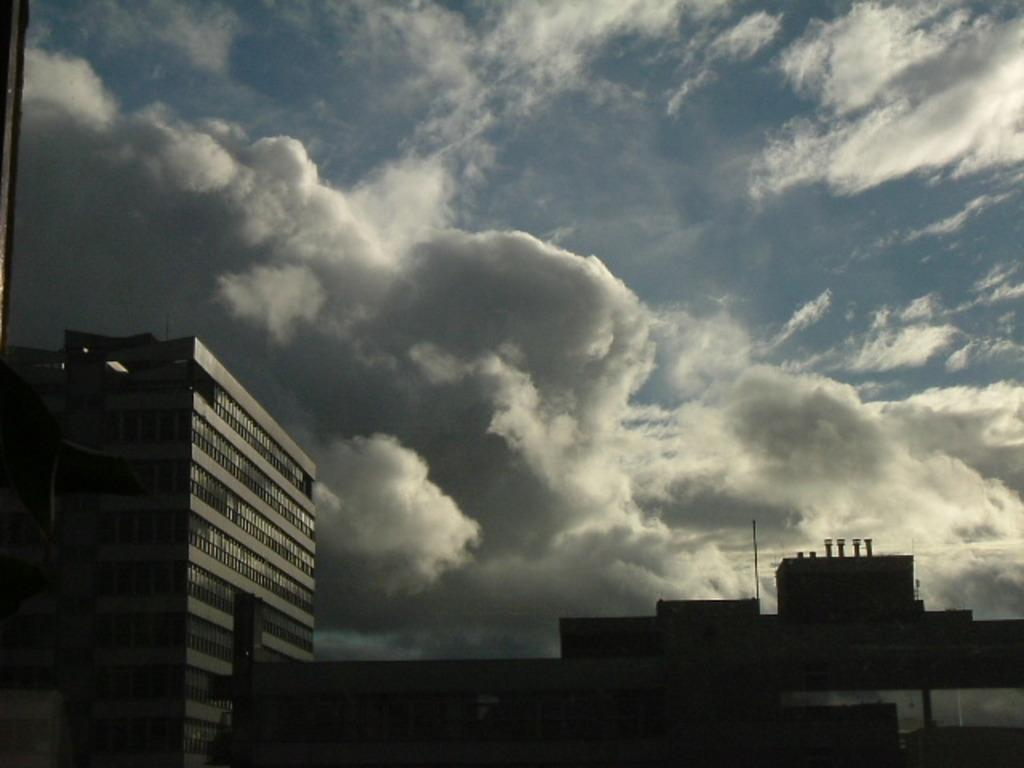What structures are located at the bottom of the image? There are buildings and poles at the bottom of the image. What can be seen above the buildings and poles in the image? The sky is visible at the top of the image. What is present in the sky in the image? Clouds are present in the sky. What type of coat is covering the buildings in the image? There is no coat covering the buildings in the image; they are not covered by any object. 